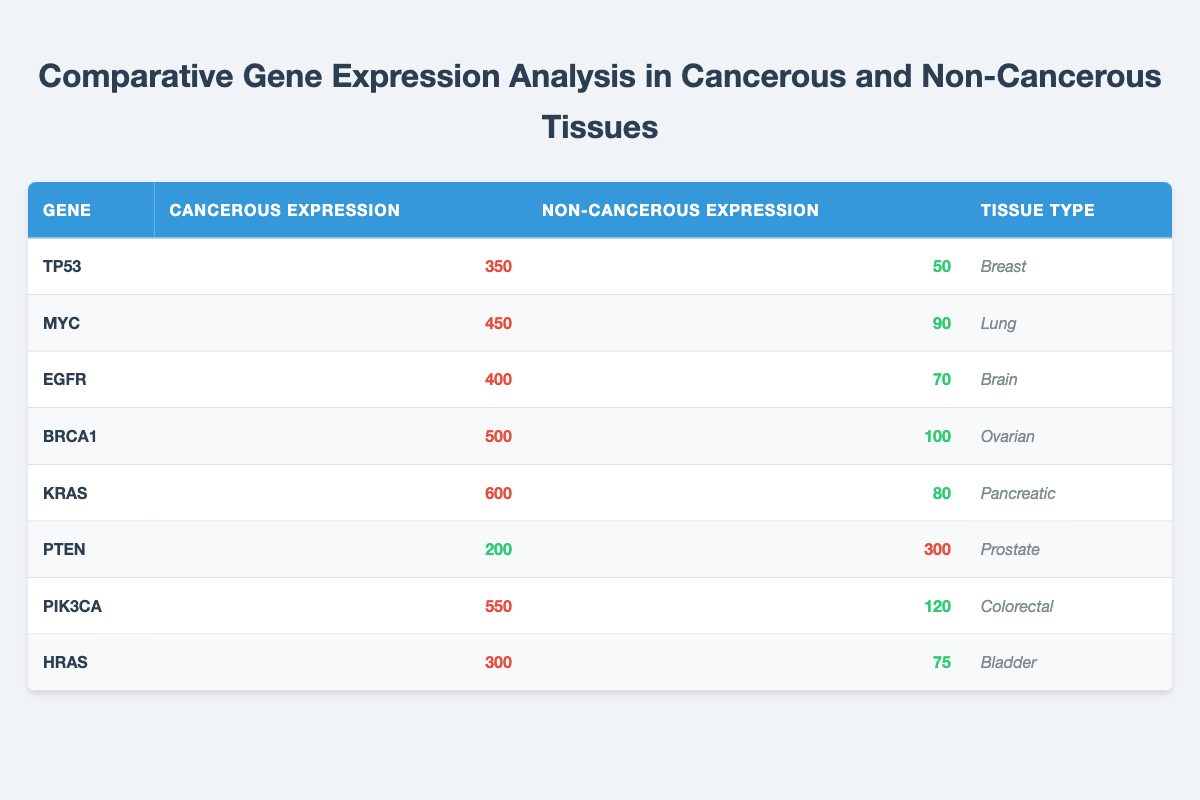What is the cancerous expression level of the gene TP53 in breast tissue? The table shows the expression value for the gene TP53 under cancerous conditions in breast tissue. It lists a cancerous expression of 350.
Answer: 350 Which gene has the highest expression in cancerous tissues? I can compare the cancerous expression values for each gene listed in the table. The gene KRAS has the highest expression at 600.
Answer: KRAS What is the difference between the cancerous and non-cancerous expression levels of the gene MYC in lung tissue? The cancerous expression for MYC is 450, and the non-cancerous expression is 90. The difference is calculated as 450 - 90 = 360.
Answer: 360 Is the non-cancerous expression of the gene PTEN higher than that of the gene BRCA1? I need to compare the non-cancerous expression levels in the table. PTEN's non-cancerous expression is 300, while BRCA1's is 100. Since 300 is greater than 100, the statement is true.
Answer: Yes What is the average cancerous expression level of all the genes listed in the table? First, I sum the cancerous expression levels: 350 + 450 + 400 + 500 + 600 + 200 + 550 + 300 = 3850. There are 8 genes, so the average is 3850/8 = 481.25.
Answer: 481.25 How many tissue types show a non-cancerous expression level above 100? I would examine the non-cancerous expression levels for each gene. The genes with non-cancerous expression exceeding 100 are PTEN (300), PIK3CA (120), and BRCA1 (100 is not greater than 100). Thus, there are 2 tissue types with levels above 100.
Answer: 2 Is the gene EGFR expressed higher in cancerous or non-cancerous tissues? For EGFR, the cancerous expression is 400, and the non-cancerous expression is 70. Since 400 is greater than 70, EGFR is expressed higher in cancerous tissues.
Answer: Cancerous tissues Which gene has the largest ratio of cancerous expression to non-cancerous expression? To find the largest ratio, I will calculate the ratio for each gene: TP53 (350/50 = 7), MYC (450/90 = 5), EGFR (400/70 ≈ 5.71), BRCA1 (500/100 = 5), KRAS (600/80 = 7.5), PTEN (200/300 ≈ 0.67), PIK3CA (550/120 ≈ 4.58), HRAS (300/75 = 4). The highest ratio is 7.5 for KRAS.
Answer: KRAS 